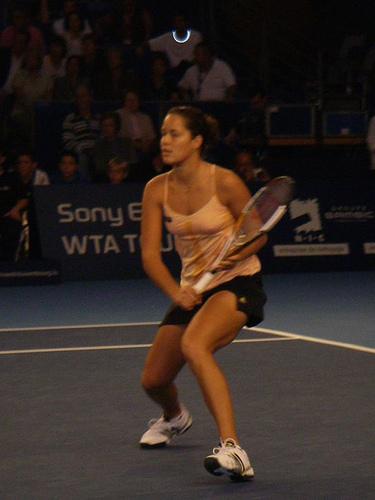What color is the woman's skirt?
Short answer required. Black. Is she angry?
Short answer required. No. What time of day is it?
Write a very short answer. Night. Are the girls turned around?
Be succinct. No. What is this girl doing?
Give a very brief answer. Playing tennis. Is the tennis player sweating?
Answer briefly. Yes. What is the ground made of?
Concise answer only. Asphalt. Is it sunny?
Concise answer only. No. Are the people wearing shoes?
Be succinct. Yes. Did the tennis player just hit the ball?
Answer briefly. No. What is the woman doing with a racket in the right hand?
Answer briefly. Playing tennis. What kind of computers are advertised?
Write a very short answer. Sony. Does the women's shirt match her shoes?
Write a very short answer. No. Is there a woman with sunglasses on top of her head?
Quick response, please. No. Who is behind the girl?
Be succinct. Audience. What color is the round object in the woman's hand?
Concise answer only. White. Which hand holds the racket?
Concise answer only. Right. What kind of competition is pictured?
Concise answer only. Tennis. What is the name brand of the tennis racket?
Short answer required. Wilson. Can you see a company's name?
Write a very short answer. Yes. What is this person doing?
Short answer required. Playing tennis. Is this woman near water?
Answer briefly. No. What is the girl holding?
Quick response, please. Tennis racket. 